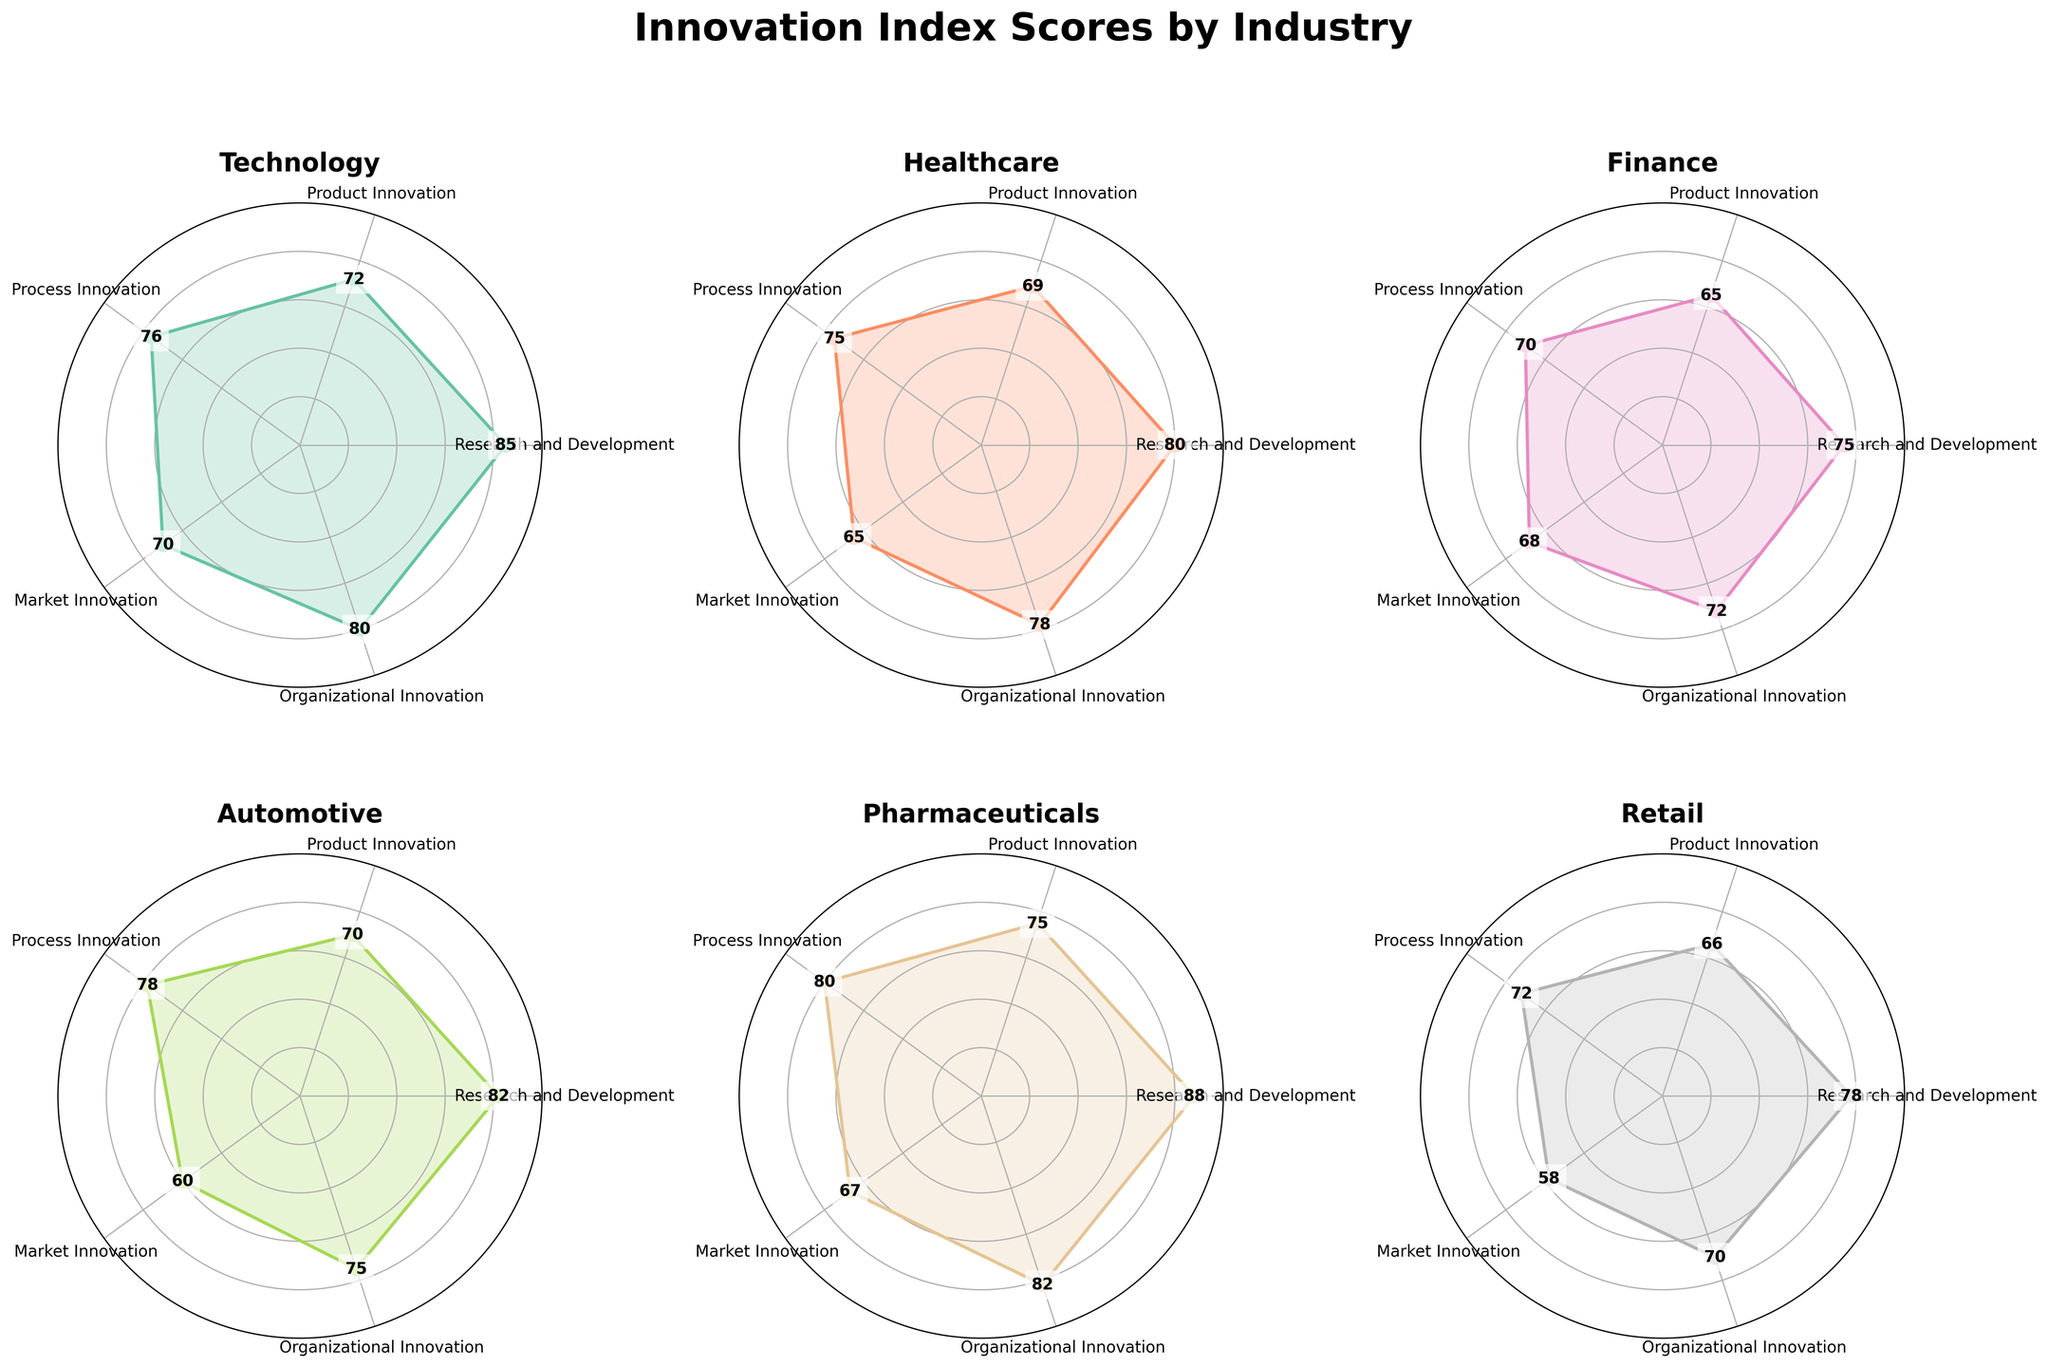Which industry has the highest Research and Development score? Examination of the Research and Development scores shows that Pharmaceuticals has the highest score of 88.
Answer: Pharmaceuticals What is the average Product Innovation score across all industries? To find the average, sum up the Product Innovation scores (72, 69, 65, 70, 75, 66) which equals 417, and then divide by the number of industries (6): 417 / 6 = 69.5.
Answer: 69.5 Which industry has the lowest score in Market Innovation? By examining the Market Innovation scores for all industries, Retail has the lowest score of 58.
Answer: Retail How much higher is the Organizational Innovation score of Pharmaceuticals compared to Finance? The Organizational Innovation score for Pharmaceuticals is 82, while for Finance it is 72. The difference is 82 - 72 = 10.
Answer: 10 Rank the industries by their Process Innovation score from highest to lowest. The Process Innovation scores are 76 (Technology), 75 (Healthcare), 70 (Finance), 78 (Automotive), 80 (Pharmaceuticals), 72 (Retail). Sorting these, the ranking is: Pharmaceuticals (80), Automotive (78), Technology (76), Healthcare (75), Finance (70), Retail (72).
Answer: Pharmaceuticals, Automotive, Technology, Healthcare, Finance, Retail What trend do you observe in the Product Innovation scores? By analyzing the Product Innovation scores across the industries, we observe a relatively narrow range with the highest score being 75 (Pharmaceuticals) and the lowest being 65 (Finance), indicating more uniform innovation in this category.
Answer: Uniform trend Which industry has the widest range of scores across all categories? By comparing the range of scores (maximum - minimum) for each industry:
- Technology: 85 - 70 = 15
- Healthcare: 80 - 65 = 15
- Finance: 75 - 65 = 10
- Automotive: 82 - 60 = 22
- Pharmaceuticals: 88 - 67 = 21
- Retail: 78 - 58 = 20
The Automotive industry has the widest range of 22.
Answer: Automotive What is the combined score of Organizational Innovation for Healthcare and Technology? The Organizational Innovation scores for Healthcare and Technology are 78 and 80 respectively. Summing these: 78 + 80 = 158.
Answer: 158 Compare the highest and lowest scores within the Technology industry. The highest score in the Technology industry is for Research and Development (85) and the lowest is for Market Innovation (70). The difference is 85 - 70 = 15.
Answer: 15 Identify an industry with consistent performance and explain your criteria. Pharmaceuticals show consistent performance with scores of 88, 75, 80, 67, and 82, all above 67 and close to the higher end of the scale. The relatively small variation indicates consistent high performance.
Answer: Pharmaceuticals 